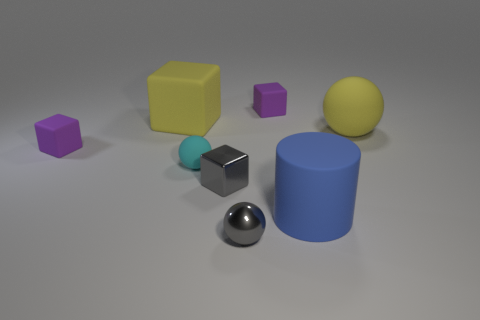Are there any other things that are the same shape as the large blue rubber object?
Provide a succinct answer. No. There is a blue matte object; is it the same shape as the metallic thing behind the large cylinder?
Offer a terse response. No. There is a yellow thing that is the same shape as the cyan thing; what size is it?
Offer a terse response. Large. Are there more tiny gray blocks than cubes?
Offer a terse response. No. What material is the sphere that is in front of the big thing in front of the big matte ball?
Make the answer very short. Metal. What is the material of the block that is the same color as the small metal ball?
Offer a terse response. Metal. Does the shiny ball have the same size as the yellow block?
Your response must be concise. No. Are there any things right of the small purple matte thing that is on the left side of the large yellow matte cube?
Provide a short and direct response. Yes. The ball that is the same color as the large cube is what size?
Ensure brevity in your answer.  Large. The blue matte thing that is in front of the yellow rubber cube has what shape?
Give a very brief answer. Cylinder. 